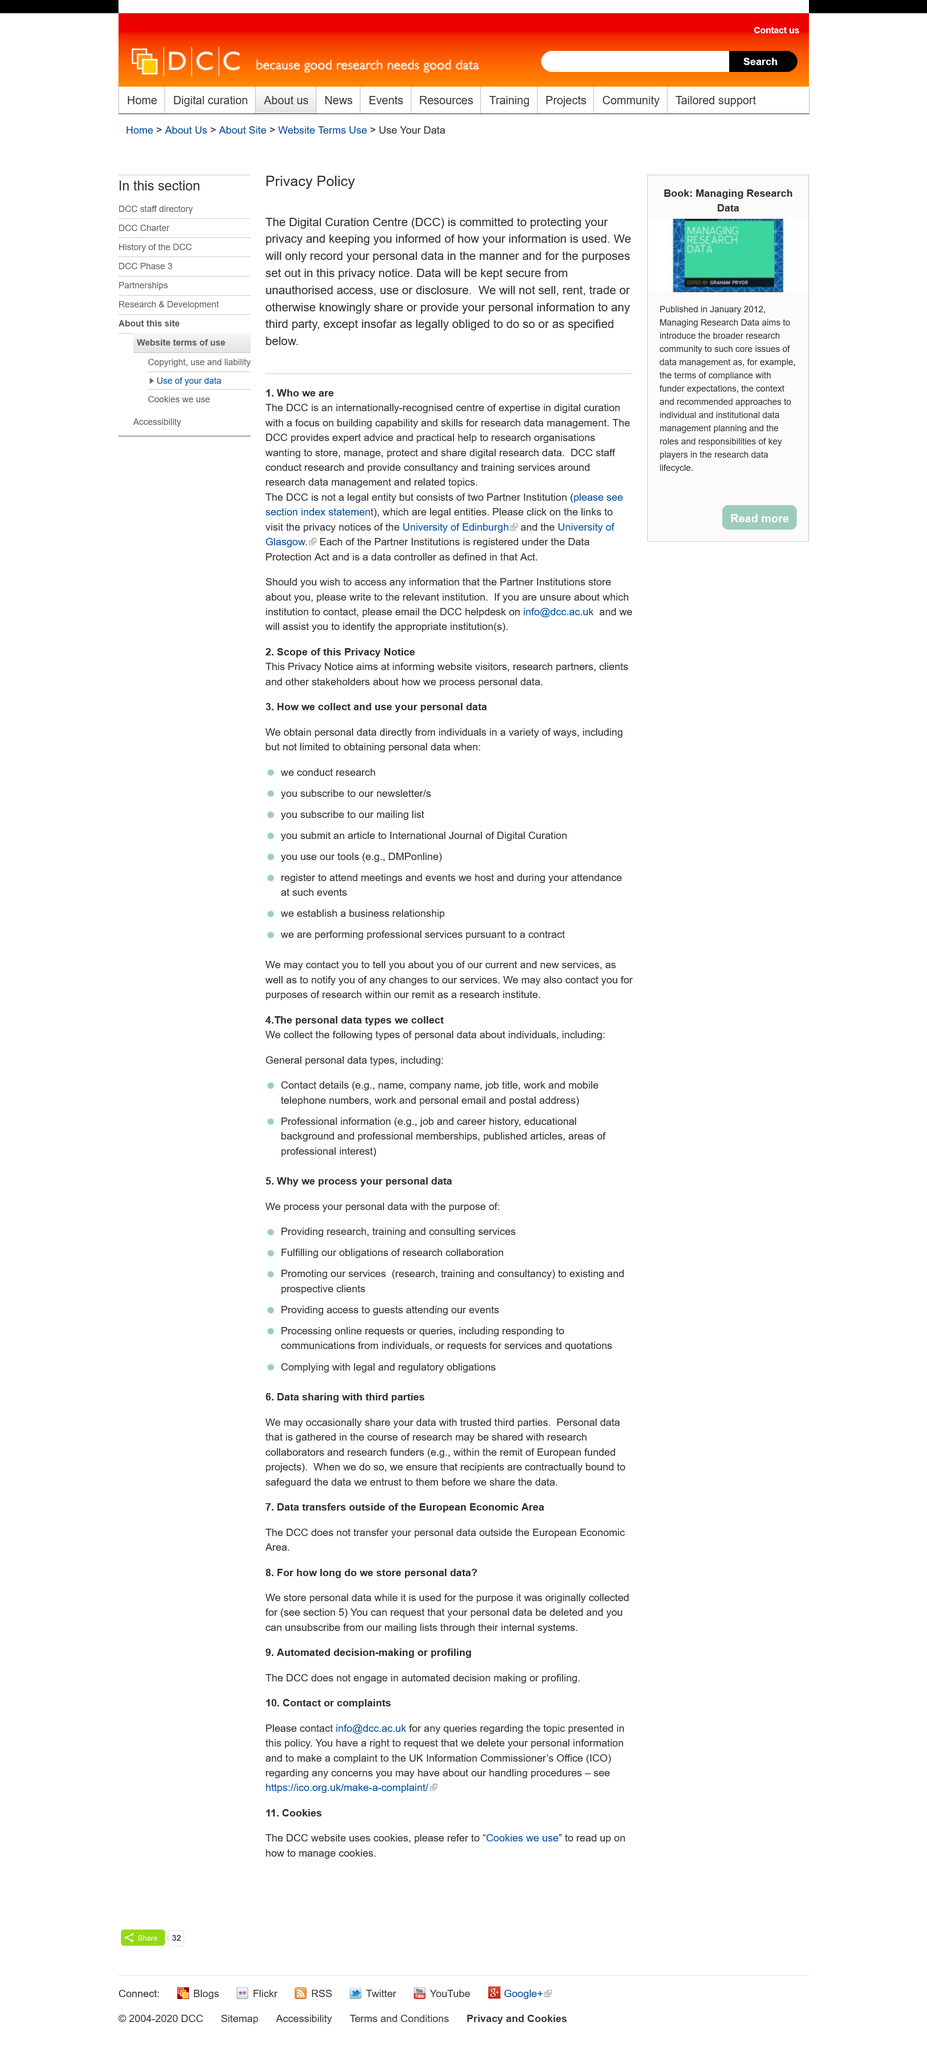Mention a couple of crucial points in this snapshot. The Digital Curation Centre is committed to protecting the privacy of its users and informing them of how their information is used. According to this Privacy Policy, data will be kept secure from unauthorized access, use, or disclosure. In this article, the abbreviation DCC refers to the Digital Curation Centre. 